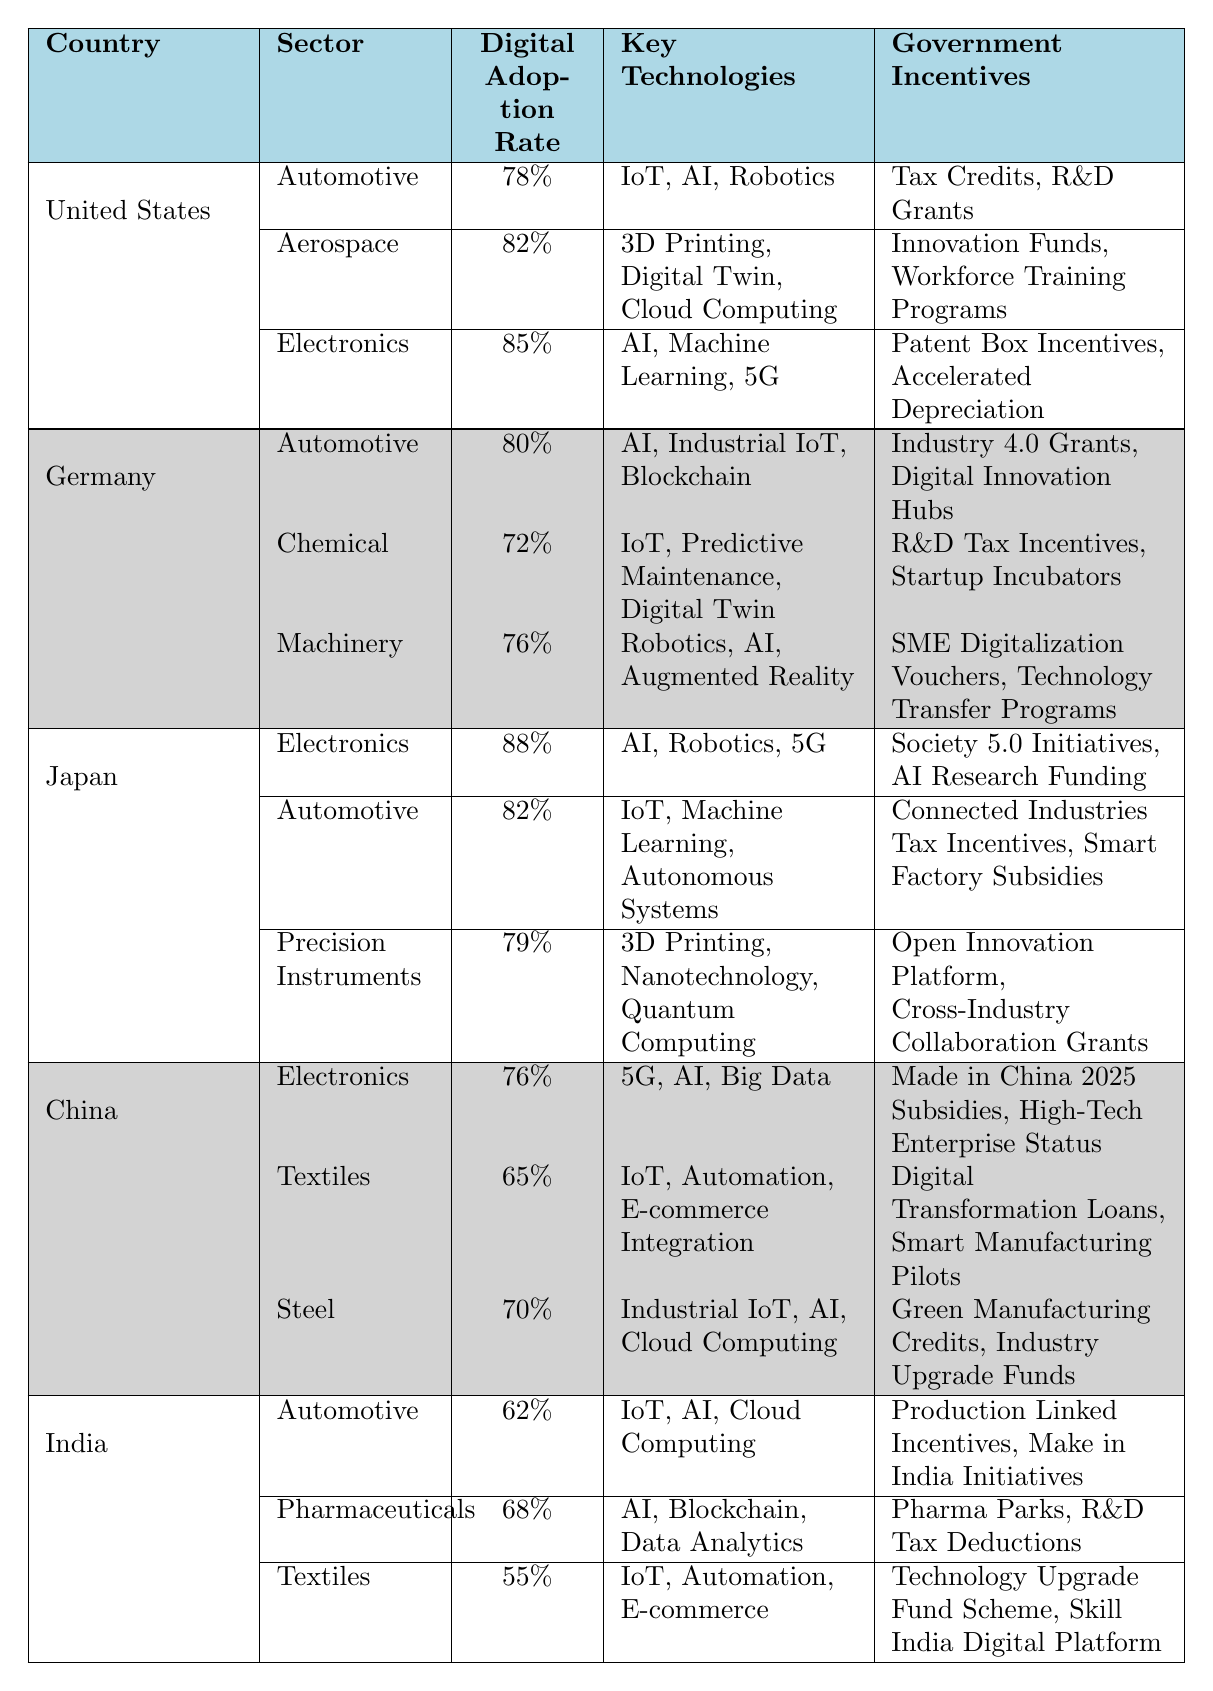What is the digital adoption rate for the Electronics sector in Japan? According to the table, the digital adoption rate for the Electronics sector in Japan is 88%.
Answer: 88% Which country has the highest digital adoption rate in the Automotive sector? The table shows that Japan has the highest digital adoption rate in the Automotive sector, at 82%, compared to the United States' 78% and Germany's 80%.
Answer: Japan What are the key technologies used in the Chemical manufacturing sector in Germany? The table lists the key technologies used in the Chemical sector in Germany as IoT, Predictive Maintenance, and Digital Twin.
Answer: IoT, Predictive Maintenance, Digital Twin What is the average digital adoption rate for the Automotive sectors across all G20 countries? The adoption rates for Automotive in the U.S. (78%), Germany (80%), Japan (82%), China (not provided) and India (62%) are added: 78 + 80 + 82 + 62 = 302. There are four completed entries, so 302/4 = 75.5.
Answer: 75.5% Do all manufacturing sectors in India have a digital adoption rate above 60%? The table indicates that the Automotive (62%), Pharmaceuticals (68%), and Textiles (55%) sectors in India do not all exceed 60%, as Textiles is below this rate.
Answer: No What are the government incentives for the Aerospace sector in the United States? The table indicates that the government incentives for the Aerospace sector in the U.S. are Innovation Funds and Workforce Training Programs.
Answer: Innovation Funds, Workforce Training Programs Which sector in Germany shows the lowest digital adoption rate, and what is that rate? The table shows that the Chemical sector in Germany has the lowest digital adoption rate at 72%.
Answer: Chemical sector, 72% How does the digital adoption rate in the Textiles sector in China compare to that in India? According to the table, China's Textiles sector has a digital adoption rate of 65%, while India's Textiles sector has a rate of 55%. Hence, China's rate is higher.
Answer: Higher in China What is the total number of key technologies listed for the Machinery sector in Germany? The table indicates that there are three key technologies listed for the Machinery sector in Germany, which are Robotics, AI, and Augmented Reality.
Answer: 3 Is there a manufacturing sector in the G20 countries that has a digital adoption rate of 85%? The table reveals that the Electronics sector in the United States has a digital adoption rate of 85%, confirming the presence of such a sector.
Answer: Yes What is the difference in digital adoption rates between the Pharmaceuticals sector in India and the Electronics sector in China? From the table, the difference is calculated as follows: 76% (Electronics in China) - 68% (Pharmaceuticals in India) = 8%.
Answer: 8% 